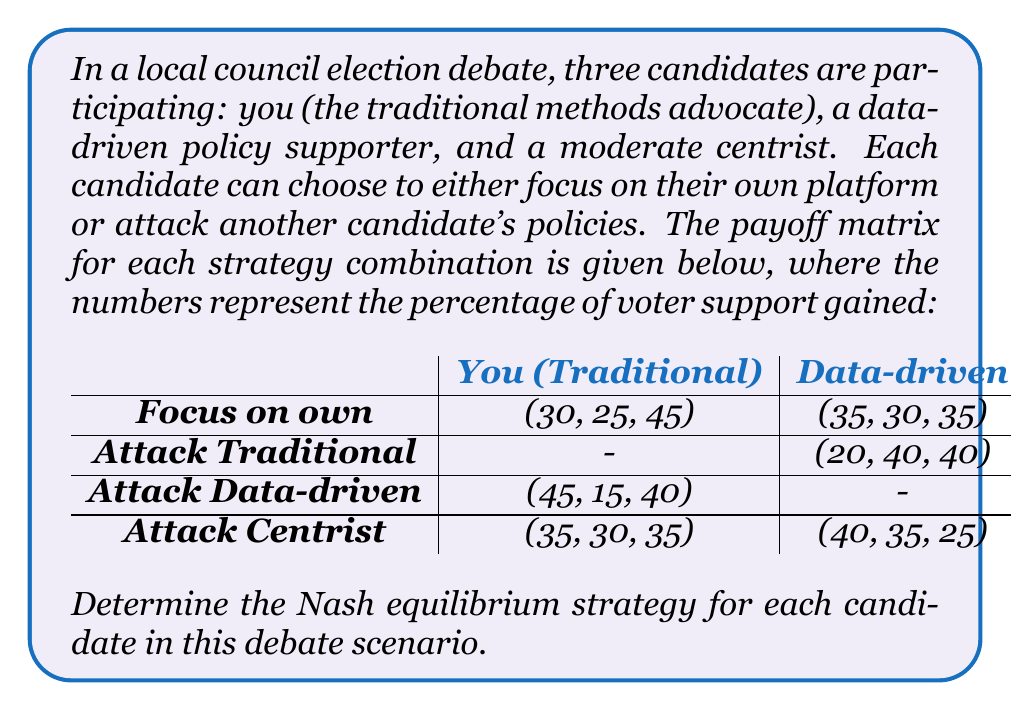Give your solution to this math problem. To find the Nash equilibrium, we need to analyze each candidate's best response to the other candidates' strategies. Let's go through this step-by-step:

1. For you (Traditional candidate):
   - If Data-driven focuses on own: Best response is to focus on own (30 > 25)
   - If Data-driven attacks Traditional: Best response is to focus on own (30 > 20)
   - If Centrist focuses on own: Best response is to attack Data-driven (45 > 40 > 35 > 30)
   - If Centrist attacks Traditional: Best response is to focus on own (30 > 25)

2. For Data-driven candidate:
   - If Traditional focuses on own: Best response is to attack Traditional (40 > 30 > 25)
   - If Traditional attacks Data-driven: Best response is to focus on own (30 > 15)
   - If Centrist focuses on own: Best response is to attack Centrist (35 > 30 > 20)
   - If Centrist attacks Data-driven: Best response is to focus on own (30 > 25)

3. For Centrist candidate:
   - If Traditional focuses on own: Best response is to focus on own (45 > 40 > 35)
   - If Traditional attacks Data-driven: Best response is to focus on own (40 > 35)
   - If Data-driven focuses on own: Best response is to focus on own (35 > 25)
   - If Data-driven attacks Traditional: Best response is to focus on own (40 > 25)

Analyzing these best responses, we can see that the only strategy combination where all candidates are playing their best response simultaneously is when:
- You (Traditional) focus on your own platform
- Data-driven focuses on their own platform
- Centrist focuses on their own platform

This combination results in the payoff (35, 30, 35), where no candidate can unilaterally improve their position by changing their strategy.
Answer: The Nash equilibrium for this debate scenario is:
You (Traditional): Focus on own platform
Data-driven: Focus on own platform
Centrist: Focus on own platform
Resulting in payoffs: (35%, 30%, 35%) 